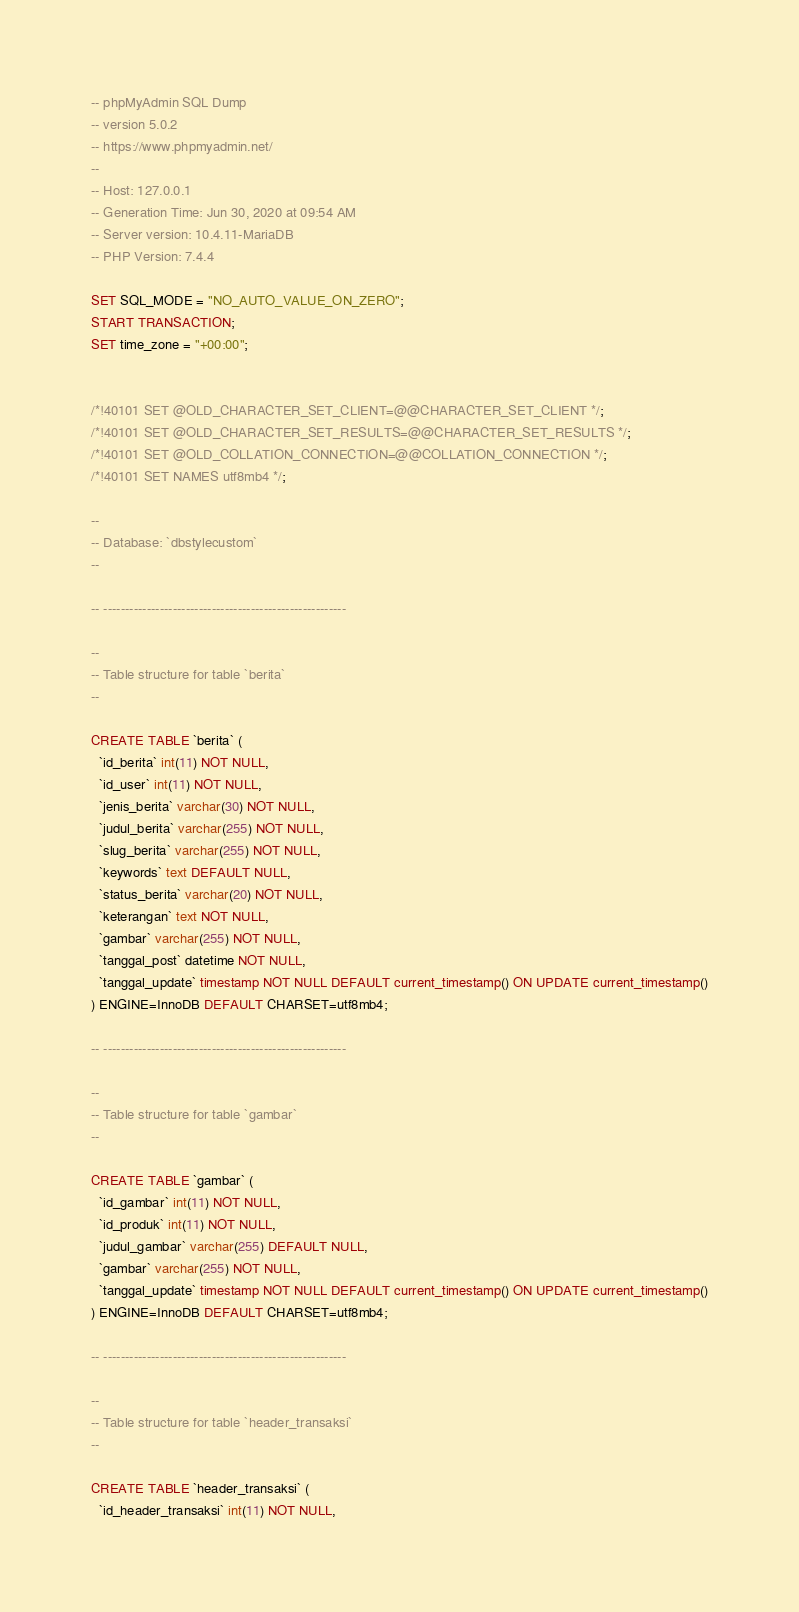<code> <loc_0><loc_0><loc_500><loc_500><_SQL_>-- phpMyAdmin SQL Dump
-- version 5.0.2
-- https://www.phpmyadmin.net/
--
-- Host: 127.0.0.1
-- Generation Time: Jun 30, 2020 at 09:54 AM
-- Server version: 10.4.11-MariaDB
-- PHP Version: 7.4.4

SET SQL_MODE = "NO_AUTO_VALUE_ON_ZERO";
START TRANSACTION;
SET time_zone = "+00:00";


/*!40101 SET @OLD_CHARACTER_SET_CLIENT=@@CHARACTER_SET_CLIENT */;
/*!40101 SET @OLD_CHARACTER_SET_RESULTS=@@CHARACTER_SET_RESULTS */;
/*!40101 SET @OLD_COLLATION_CONNECTION=@@COLLATION_CONNECTION */;
/*!40101 SET NAMES utf8mb4 */;

--
-- Database: `dbstylecustom`
--

-- --------------------------------------------------------

--
-- Table structure for table `berita`
--

CREATE TABLE `berita` (
  `id_berita` int(11) NOT NULL,
  `id_user` int(11) NOT NULL,
  `jenis_berita` varchar(30) NOT NULL,
  `judul_berita` varchar(255) NOT NULL,
  `slug_berita` varchar(255) NOT NULL,
  `keywords` text DEFAULT NULL,
  `status_berita` varchar(20) NOT NULL,
  `keterangan` text NOT NULL,
  `gambar` varchar(255) NOT NULL,
  `tanggal_post` datetime NOT NULL,
  `tanggal_update` timestamp NOT NULL DEFAULT current_timestamp() ON UPDATE current_timestamp()
) ENGINE=InnoDB DEFAULT CHARSET=utf8mb4;

-- --------------------------------------------------------

--
-- Table structure for table `gambar`
--

CREATE TABLE `gambar` (
  `id_gambar` int(11) NOT NULL,
  `id_produk` int(11) NOT NULL,
  `judul_gambar` varchar(255) DEFAULT NULL,
  `gambar` varchar(255) NOT NULL,
  `tanggal_update` timestamp NOT NULL DEFAULT current_timestamp() ON UPDATE current_timestamp()
) ENGINE=InnoDB DEFAULT CHARSET=utf8mb4;

-- --------------------------------------------------------

--
-- Table structure for table `header_transaksi`
--

CREATE TABLE `header_transaksi` (
  `id_header_transaksi` int(11) NOT NULL,</code> 